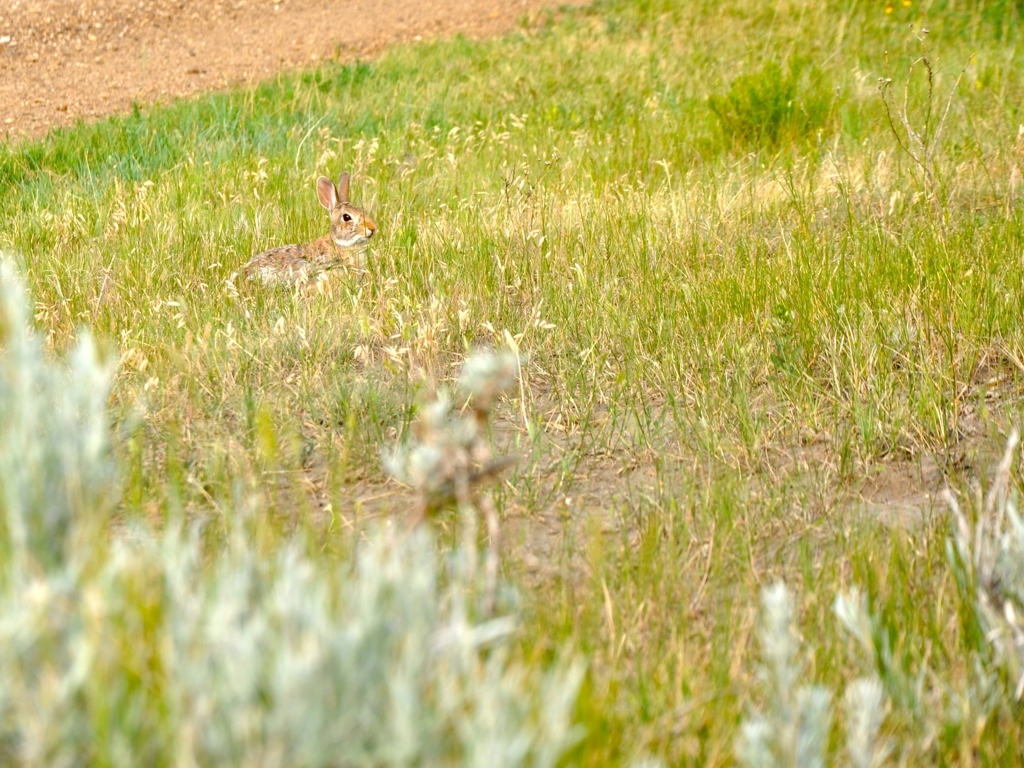What is the focal point of this image? The focal point is the rabbit, nestled quietly among the grass. It draws the eye due to its contrasting color and the fact that it's a living element within the stillness of its environment. Is the rabbit native to this environment? Yes, it appears to be a type of wild rabbit that is well-adapted to meadow and grassland habitats where it can find food and have cover from predators. 